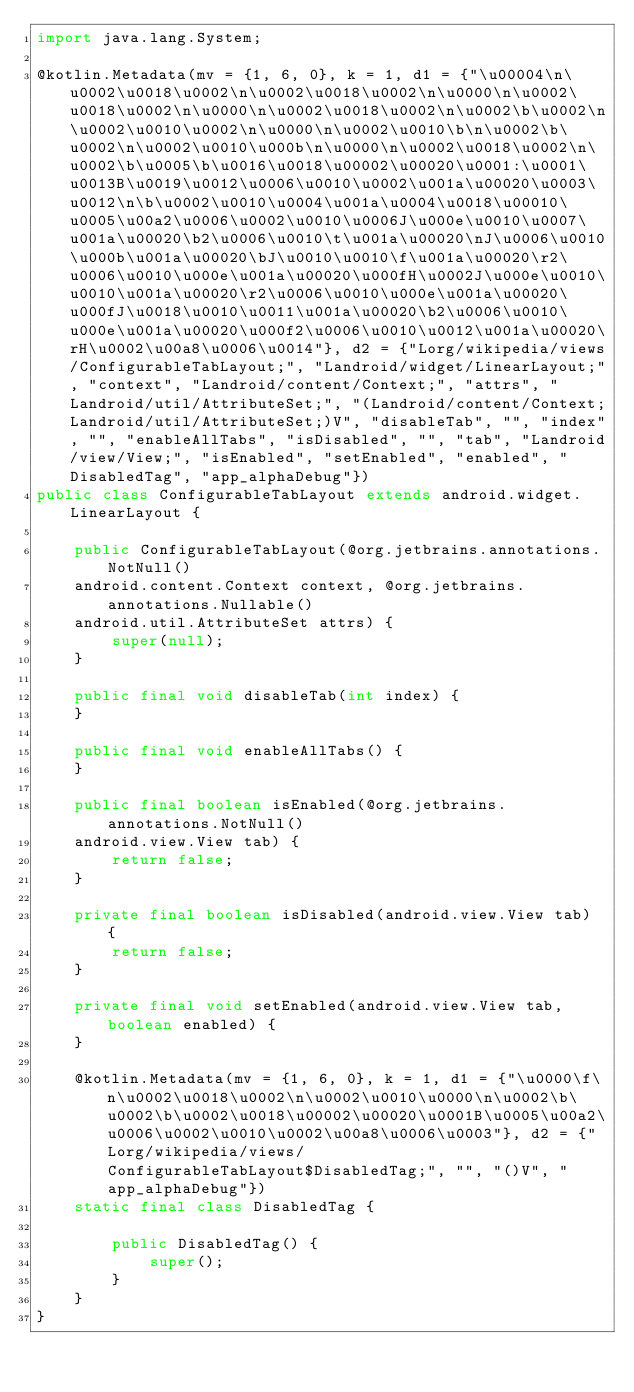Convert code to text. <code><loc_0><loc_0><loc_500><loc_500><_Java_>import java.lang.System;

@kotlin.Metadata(mv = {1, 6, 0}, k = 1, d1 = {"\u00004\n\u0002\u0018\u0002\n\u0002\u0018\u0002\n\u0000\n\u0002\u0018\u0002\n\u0000\n\u0002\u0018\u0002\n\u0002\b\u0002\n\u0002\u0010\u0002\n\u0000\n\u0002\u0010\b\n\u0002\b\u0002\n\u0002\u0010\u000b\n\u0000\n\u0002\u0018\u0002\n\u0002\b\u0005\b\u0016\u0018\u00002\u00020\u0001:\u0001\u0013B\u0019\u0012\u0006\u0010\u0002\u001a\u00020\u0003\u0012\n\b\u0002\u0010\u0004\u001a\u0004\u0018\u00010\u0005\u00a2\u0006\u0002\u0010\u0006J\u000e\u0010\u0007\u001a\u00020\b2\u0006\u0010\t\u001a\u00020\nJ\u0006\u0010\u000b\u001a\u00020\bJ\u0010\u0010\f\u001a\u00020\r2\u0006\u0010\u000e\u001a\u00020\u000fH\u0002J\u000e\u0010\u0010\u001a\u00020\r2\u0006\u0010\u000e\u001a\u00020\u000fJ\u0018\u0010\u0011\u001a\u00020\b2\u0006\u0010\u000e\u001a\u00020\u000f2\u0006\u0010\u0012\u001a\u00020\rH\u0002\u00a8\u0006\u0014"}, d2 = {"Lorg/wikipedia/views/ConfigurableTabLayout;", "Landroid/widget/LinearLayout;", "context", "Landroid/content/Context;", "attrs", "Landroid/util/AttributeSet;", "(Landroid/content/Context;Landroid/util/AttributeSet;)V", "disableTab", "", "index", "", "enableAllTabs", "isDisabled", "", "tab", "Landroid/view/View;", "isEnabled", "setEnabled", "enabled", "DisabledTag", "app_alphaDebug"})
public class ConfigurableTabLayout extends android.widget.LinearLayout {
    
    public ConfigurableTabLayout(@org.jetbrains.annotations.NotNull()
    android.content.Context context, @org.jetbrains.annotations.Nullable()
    android.util.AttributeSet attrs) {
        super(null);
    }
    
    public final void disableTab(int index) {
    }
    
    public final void enableAllTabs() {
    }
    
    public final boolean isEnabled(@org.jetbrains.annotations.NotNull()
    android.view.View tab) {
        return false;
    }
    
    private final boolean isDisabled(android.view.View tab) {
        return false;
    }
    
    private final void setEnabled(android.view.View tab, boolean enabled) {
    }
    
    @kotlin.Metadata(mv = {1, 6, 0}, k = 1, d1 = {"\u0000\f\n\u0002\u0018\u0002\n\u0002\u0010\u0000\n\u0002\b\u0002\b\u0002\u0018\u00002\u00020\u0001B\u0005\u00a2\u0006\u0002\u0010\u0002\u00a8\u0006\u0003"}, d2 = {"Lorg/wikipedia/views/ConfigurableTabLayout$DisabledTag;", "", "()V", "app_alphaDebug"})
    static final class DisabledTag {
        
        public DisabledTag() {
            super();
        }
    }
}</code> 